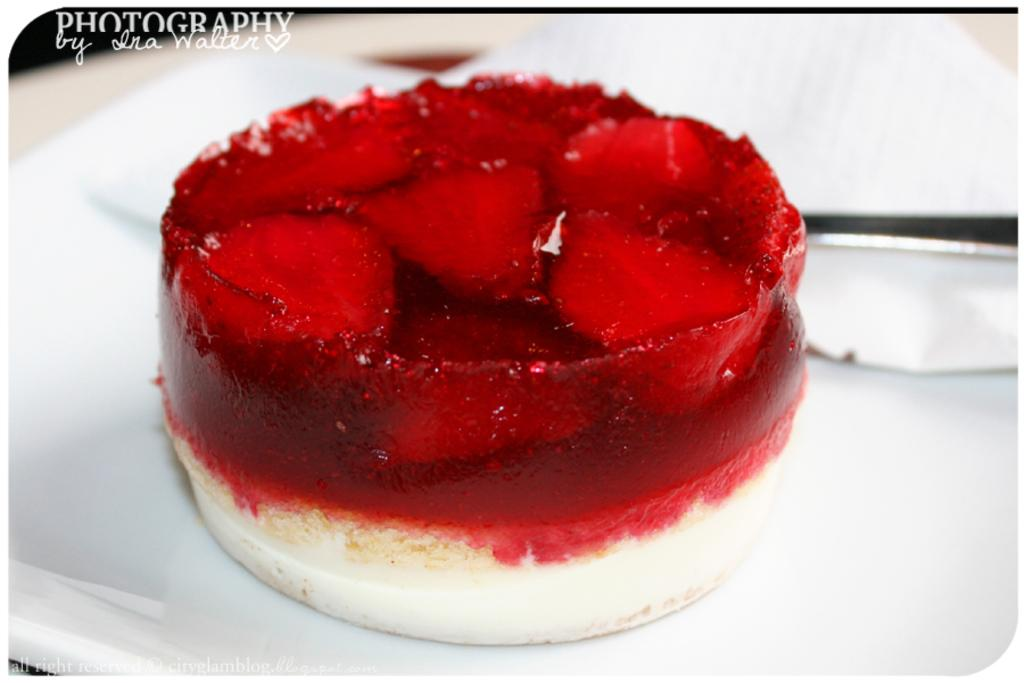What is the main subject of the image? The main subject of the image is a cake. How is the cake positioned in the image? The cake is on a plate in the image. What colors are used to decorate the cake? The cake is red and cream in color. Is there any text or writing on the cake? Yes, there is text at the top of the cake. What type of rake is being used to harvest the field in the image? There is no rake or field present in the image; it features a cake with text on it. Can you see a veil on the cake in the image? There is no veil present on the cake in the image. 